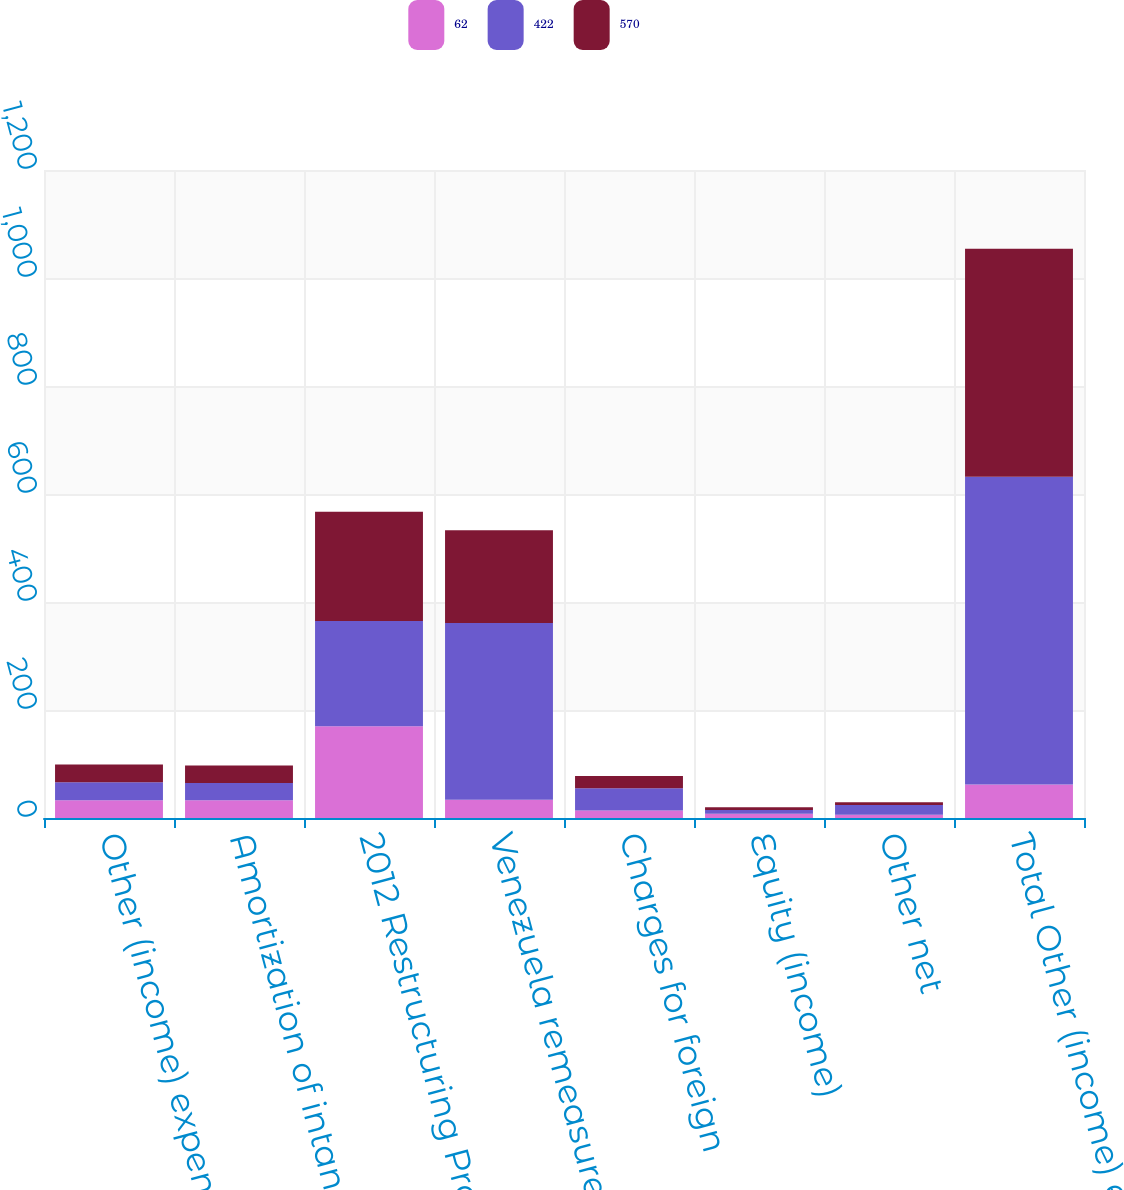Convert chart. <chart><loc_0><loc_0><loc_500><loc_500><stacked_bar_chart><ecel><fcel>Other (income) expense net<fcel>Amortization of intangible<fcel>2012 Restructuring Program<fcel>Venezuela remeasurement<fcel>Charges for foreign<fcel>Equity (income)<fcel>Other net<fcel>Total Other (income) expense<nl><fcel>62<fcel>33<fcel>33<fcel>170<fcel>34<fcel>14<fcel>8<fcel>6<fcel>62<nl><fcel>422<fcel>33<fcel>32<fcel>195<fcel>327<fcel>41<fcel>7<fcel>18<fcel>570<nl><fcel>570<fcel>33<fcel>32<fcel>202<fcel>172<fcel>23<fcel>5<fcel>5<fcel>422<nl></chart> 